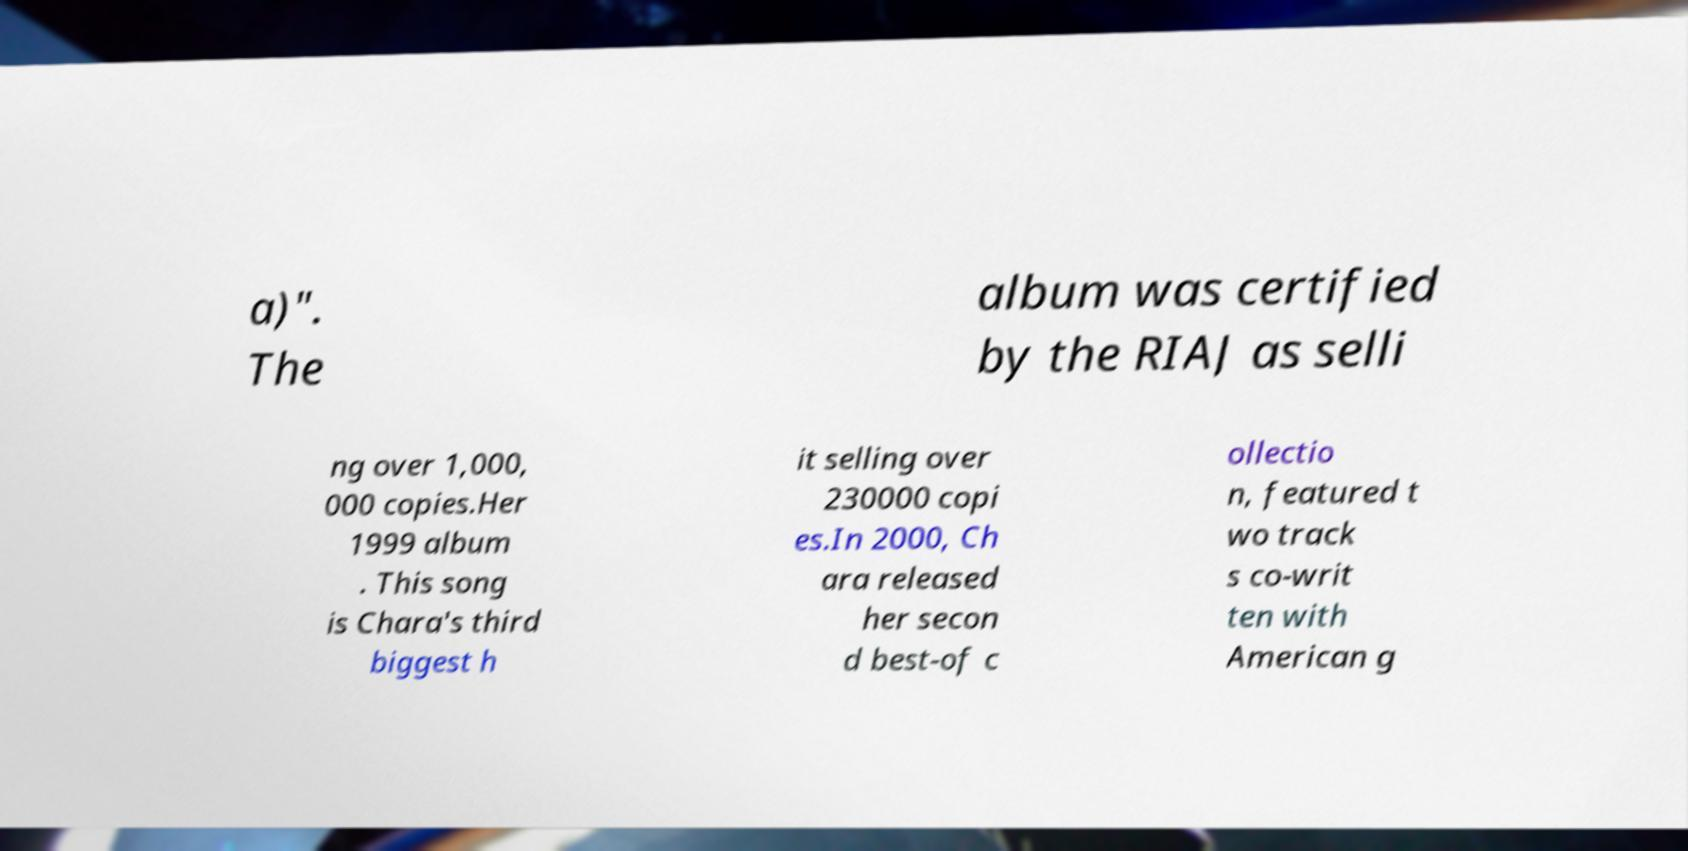Can you accurately transcribe the text from the provided image for me? a)". The album was certified by the RIAJ as selli ng over 1,000, 000 copies.Her 1999 album . This song is Chara's third biggest h it selling over 230000 copi es.In 2000, Ch ara released her secon d best-of c ollectio n, featured t wo track s co-writ ten with American g 